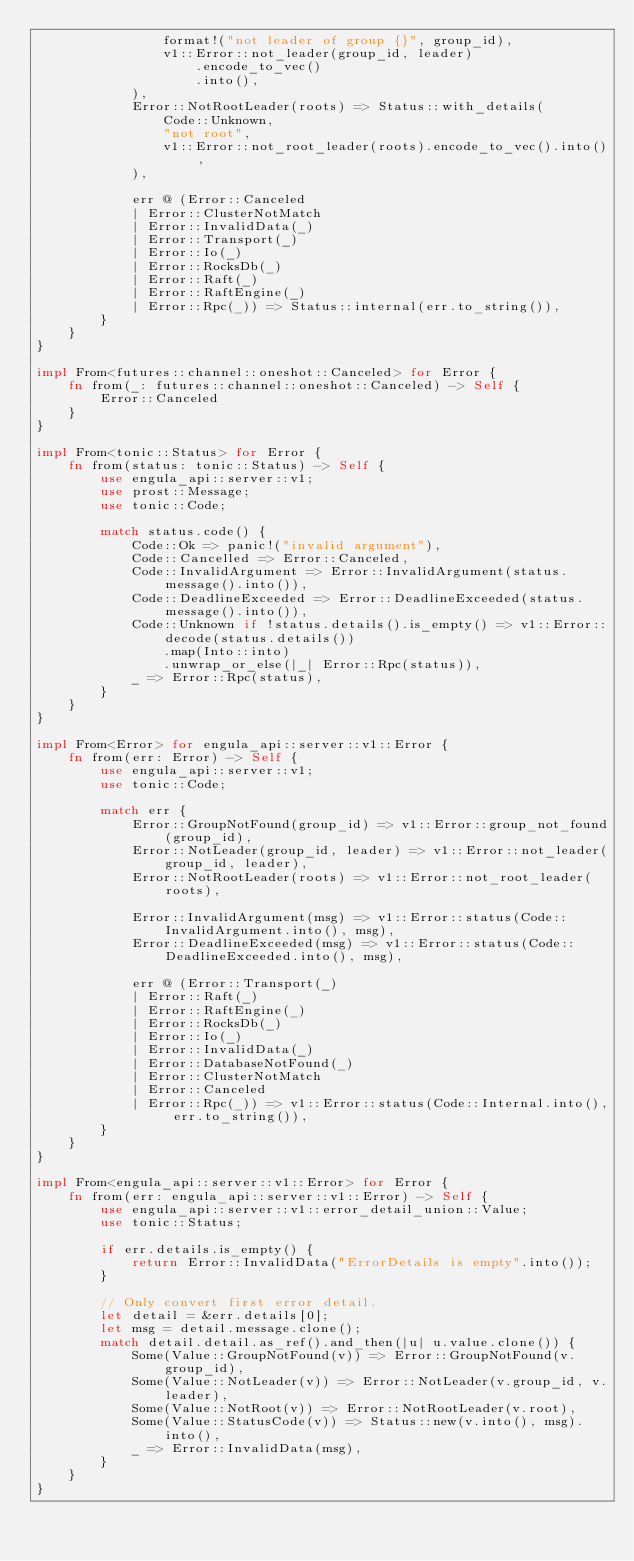<code> <loc_0><loc_0><loc_500><loc_500><_Rust_>                format!("not leader of group {}", group_id),
                v1::Error::not_leader(group_id, leader)
                    .encode_to_vec()
                    .into(),
            ),
            Error::NotRootLeader(roots) => Status::with_details(
                Code::Unknown,
                "not root",
                v1::Error::not_root_leader(roots).encode_to_vec().into(),
            ),

            err @ (Error::Canceled
            | Error::ClusterNotMatch
            | Error::InvalidData(_)
            | Error::Transport(_)
            | Error::Io(_)
            | Error::RocksDb(_)
            | Error::Raft(_)
            | Error::RaftEngine(_)
            | Error::Rpc(_)) => Status::internal(err.to_string()),
        }
    }
}

impl From<futures::channel::oneshot::Canceled> for Error {
    fn from(_: futures::channel::oneshot::Canceled) -> Self {
        Error::Canceled
    }
}

impl From<tonic::Status> for Error {
    fn from(status: tonic::Status) -> Self {
        use engula_api::server::v1;
        use prost::Message;
        use tonic::Code;

        match status.code() {
            Code::Ok => panic!("invalid argument"),
            Code::Cancelled => Error::Canceled,
            Code::InvalidArgument => Error::InvalidArgument(status.message().into()),
            Code::DeadlineExceeded => Error::DeadlineExceeded(status.message().into()),
            Code::Unknown if !status.details().is_empty() => v1::Error::decode(status.details())
                .map(Into::into)
                .unwrap_or_else(|_| Error::Rpc(status)),
            _ => Error::Rpc(status),
        }
    }
}

impl From<Error> for engula_api::server::v1::Error {
    fn from(err: Error) -> Self {
        use engula_api::server::v1;
        use tonic::Code;

        match err {
            Error::GroupNotFound(group_id) => v1::Error::group_not_found(group_id),
            Error::NotLeader(group_id, leader) => v1::Error::not_leader(group_id, leader),
            Error::NotRootLeader(roots) => v1::Error::not_root_leader(roots),

            Error::InvalidArgument(msg) => v1::Error::status(Code::InvalidArgument.into(), msg),
            Error::DeadlineExceeded(msg) => v1::Error::status(Code::DeadlineExceeded.into(), msg),

            err @ (Error::Transport(_)
            | Error::Raft(_)
            | Error::RaftEngine(_)
            | Error::RocksDb(_)
            | Error::Io(_)
            | Error::InvalidData(_)
            | Error::DatabaseNotFound(_)
            | Error::ClusterNotMatch
            | Error::Canceled
            | Error::Rpc(_)) => v1::Error::status(Code::Internal.into(), err.to_string()),
        }
    }
}

impl From<engula_api::server::v1::Error> for Error {
    fn from(err: engula_api::server::v1::Error) -> Self {
        use engula_api::server::v1::error_detail_union::Value;
        use tonic::Status;

        if err.details.is_empty() {
            return Error::InvalidData("ErrorDetails is empty".into());
        }

        // Only convert first error detail.
        let detail = &err.details[0];
        let msg = detail.message.clone();
        match detail.detail.as_ref().and_then(|u| u.value.clone()) {
            Some(Value::GroupNotFound(v)) => Error::GroupNotFound(v.group_id),
            Some(Value::NotLeader(v)) => Error::NotLeader(v.group_id, v.leader),
            Some(Value::NotRoot(v)) => Error::NotRootLeader(v.root),
            Some(Value::StatusCode(v)) => Status::new(v.into(), msg).into(),
            _ => Error::InvalidData(msg),
        }
    }
}
</code> 